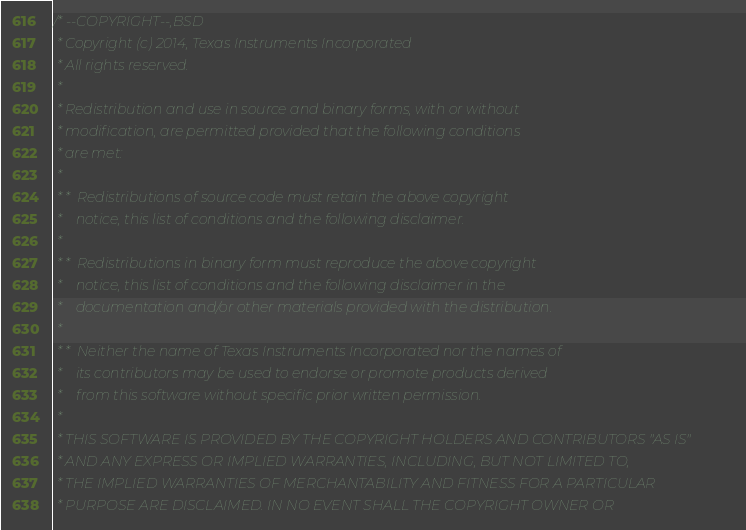<code> <loc_0><loc_0><loc_500><loc_500><_C_>/* --COPYRIGHT--,BSD
 * Copyright (c) 2014, Texas Instruments Incorporated
 * All rights reserved.
 *
 * Redistribution and use in source and binary forms, with or without
 * modification, are permitted provided that the following conditions
 * are met:
 *
 * *  Redistributions of source code must retain the above copyright
 *    notice, this list of conditions and the following disclaimer.
 *
 * *  Redistributions in binary form must reproduce the above copyright
 *    notice, this list of conditions and the following disclaimer in the
 *    documentation and/or other materials provided with the distribution.
 *
 * *  Neither the name of Texas Instruments Incorporated nor the names of
 *    its contributors may be used to endorse or promote products derived
 *    from this software without specific prior written permission.
 *
 * THIS SOFTWARE IS PROVIDED BY THE COPYRIGHT HOLDERS AND CONTRIBUTORS "AS IS"
 * AND ANY EXPRESS OR IMPLIED WARRANTIES, INCLUDING, BUT NOT LIMITED TO,
 * THE IMPLIED WARRANTIES OF MERCHANTABILITY AND FITNESS FOR A PARTICULAR
 * PURPOSE ARE DISCLAIMED. IN NO EVENT SHALL THE COPYRIGHT OWNER OR</code> 